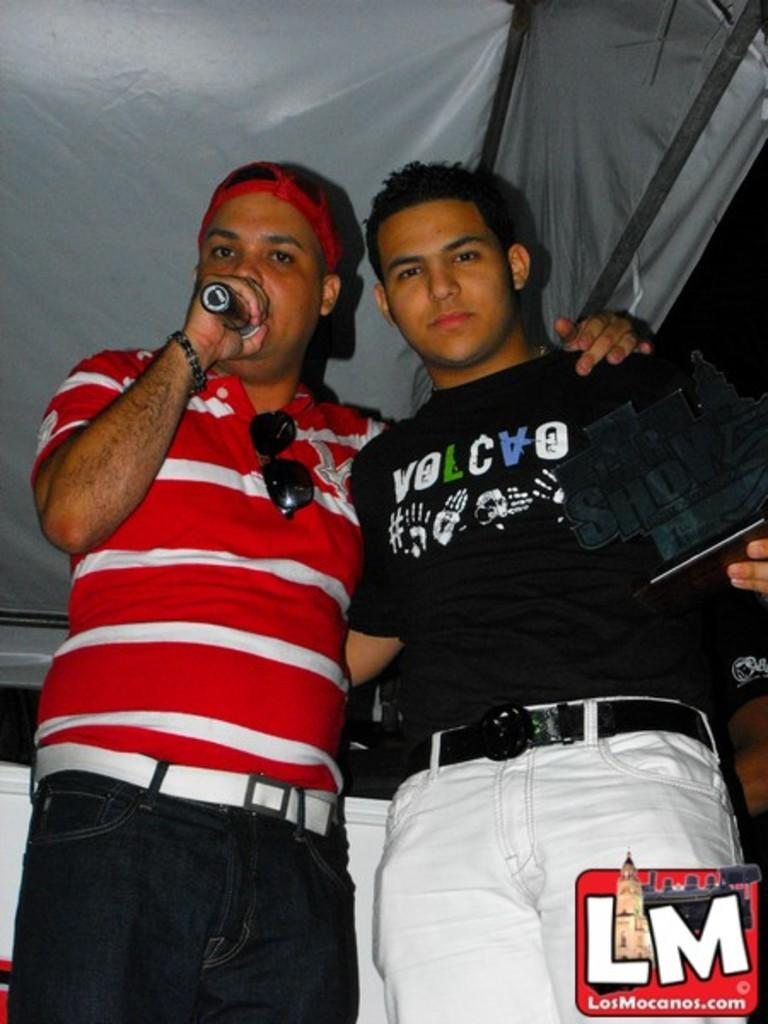<image>
Provide a brief description of the given image. Two guys stand together with one wearing a shirt that says volcvo. 